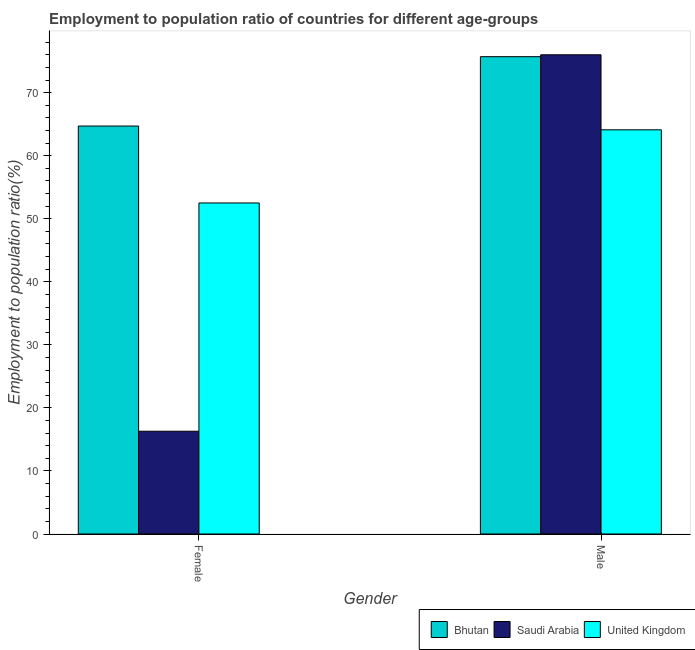How many bars are there on the 2nd tick from the left?
Offer a very short reply. 3. How many bars are there on the 2nd tick from the right?
Your answer should be compact. 3. What is the employment to population ratio(male) in Bhutan?
Provide a succinct answer. 75.7. Across all countries, what is the maximum employment to population ratio(male)?
Make the answer very short. 76. Across all countries, what is the minimum employment to population ratio(female)?
Make the answer very short. 16.3. In which country was the employment to population ratio(female) maximum?
Ensure brevity in your answer.  Bhutan. In which country was the employment to population ratio(male) minimum?
Offer a terse response. United Kingdom. What is the total employment to population ratio(male) in the graph?
Keep it short and to the point. 215.8. What is the difference between the employment to population ratio(male) in United Kingdom and that in Bhutan?
Offer a terse response. -11.6. What is the difference between the employment to population ratio(male) in Saudi Arabia and the employment to population ratio(female) in Bhutan?
Offer a terse response. 11.3. What is the average employment to population ratio(female) per country?
Keep it short and to the point. 44.5. What is the difference between the employment to population ratio(female) and employment to population ratio(male) in United Kingdom?
Provide a succinct answer. -11.6. What is the ratio of the employment to population ratio(female) in United Kingdom to that in Bhutan?
Offer a very short reply. 0.81. Is the employment to population ratio(female) in Saudi Arabia less than that in Bhutan?
Your answer should be compact. Yes. What does the 1st bar from the left in Male represents?
Ensure brevity in your answer.  Bhutan. What does the 3rd bar from the right in Female represents?
Offer a terse response. Bhutan. Are all the bars in the graph horizontal?
Your answer should be very brief. No. Does the graph contain any zero values?
Give a very brief answer. No. Where does the legend appear in the graph?
Your answer should be compact. Bottom right. How many legend labels are there?
Provide a short and direct response. 3. What is the title of the graph?
Your response must be concise. Employment to population ratio of countries for different age-groups. Does "Rwanda" appear as one of the legend labels in the graph?
Ensure brevity in your answer.  No. What is the label or title of the X-axis?
Your answer should be compact. Gender. What is the label or title of the Y-axis?
Your response must be concise. Employment to population ratio(%). What is the Employment to population ratio(%) of Bhutan in Female?
Make the answer very short. 64.7. What is the Employment to population ratio(%) in Saudi Arabia in Female?
Offer a very short reply. 16.3. What is the Employment to population ratio(%) in United Kingdom in Female?
Offer a very short reply. 52.5. What is the Employment to population ratio(%) of Bhutan in Male?
Your answer should be very brief. 75.7. What is the Employment to population ratio(%) of Saudi Arabia in Male?
Offer a very short reply. 76. What is the Employment to population ratio(%) in United Kingdom in Male?
Provide a succinct answer. 64.1. Across all Gender, what is the maximum Employment to population ratio(%) of Bhutan?
Offer a terse response. 75.7. Across all Gender, what is the maximum Employment to population ratio(%) in Saudi Arabia?
Provide a short and direct response. 76. Across all Gender, what is the maximum Employment to population ratio(%) of United Kingdom?
Keep it short and to the point. 64.1. Across all Gender, what is the minimum Employment to population ratio(%) in Bhutan?
Keep it short and to the point. 64.7. Across all Gender, what is the minimum Employment to population ratio(%) in Saudi Arabia?
Provide a short and direct response. 16.3. Across all Gender, what is the minimum Employment to population ratio(%) of United Kingdom?
Ensure brevity in your answer.  52.5. What is the total Employment to population ratio(%) of Bhutan in the graph?
Offer a terse response. 140.4. What is the total Employment to population ratio(%) of Saudi Arabia in the graph?
Your response must be concise. 92.3. What is the total Employment to population ratio(%) in United Kingdom in the graph?
Your answer should be compact. 116.6. What is the difference between the Employment to population ratio(%) of Bhutan in Female and that in Male?
Ensure brevity in your answer.  -11. What is the difference between the Employment to population ratio(%) of Saudi Arabia in Female and that in Male?
Your answer should be very brief. -59.7. What is the difference between the Employment to population ratio(%) of Saudi Arabia in Female and the Employment to population ratio(%) of United Kingdom in Male?
Ensure brevity in your answer.  -47.8. What is the average Employment to population ratio(%) of Bhutan per Gender?
Your answer should be very brief. 70.2. What is the average Employment to population ratio(%) in Saudi Arabia per Gender?
Give a very brief answer. 46.15. What is the average Employment to population ratio(%) in United Kingdom per Gender?
Ensure brevity in your answer.  58.3. What is the difference between the Employment to population ratio(%) of Bhutan and Employment to population ratio(%) of Saudi Arabia in Female?
Keep it short and to the point. 48.4. What is the difference between the Employment to population ratio(%) of Bhutan and Employment to population ratio(%) of United Kingdom in Female?
Make the answer very short. 12.2. What is the difference between the Employment to population ratio(%) in Saudi Arabia and Employment to population ratio(%) in United Kingdom in Female?
Keep it short and to the point. -36.2. What is the difference between the Employment to population ratio(%) in Bhutan and Employment to population ratio(%) in United Kingdom in Male?
Ensure brevity in your answer.  11.6. What is the ratio of the Employment to population ratio(%) of Bhutan in Female to that in Male?
Your response must be concise. 0.85. What is the ratio of the Employment to population ratio(%) in Saudi Arabia in Female to that in Male?
Give a very brief answer. 0.21. What is the ratio of the Employment to population ratio(%) in United Kingdom in Female to that in Male?
Provide a succinct answer. 0.82. What is the difference between the highest and the second highest Employment to population ratio(%) of Saudi Arabia?
Keep it short and to the point. 59.7. What is the difference between the highest and the second highest Employment to population ratio(%) of United Kingdom?
Make the answer very short. 11.6. What is the difference between the highest and the lowest Employment to population ratio(%) of Saudi Arabia?
Your answer should be very brief. 59.7. What is the difference between the highest and the lowest Employment to population ratio(%) of United Kingdom?
Provide a succinct answer. 11.6. 